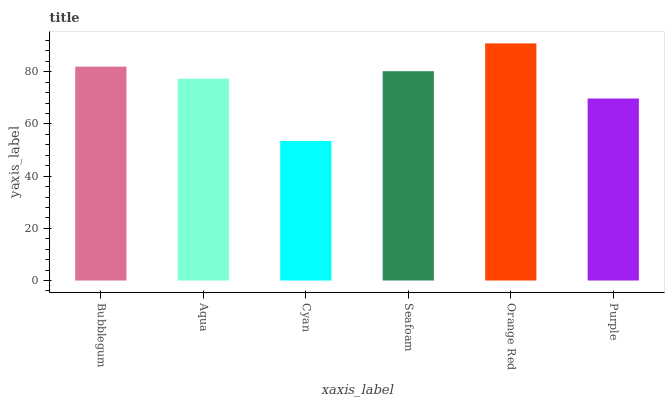Is Cyan the minimum?
Answer yes or no. Yes. Is Orange Red the maximum?
Answer yes or no. Yes. Is Aqua the minimum?
Answer yes or no. No. Is Aqua the maximum?
Answer yes or no. No. Is Bubblegum greater than Aqua?
Answer yes or no. Yes. Is Aqua less than Bubblegum?
Answer yes or no. Yes. Is Aqua greater than Bubblegum?
Answer yes or no. No. Is Bubblegum less than Aqua?
Answer yes or no. No. Is Seafoam the high median?
Answer yes or no. Yes. Is Aqua the low median?
Answer yes or no. Yes. Is Aqua the high median?
Answer yes or no. No. Is Purple the low median?
Answer yes or no. No. 